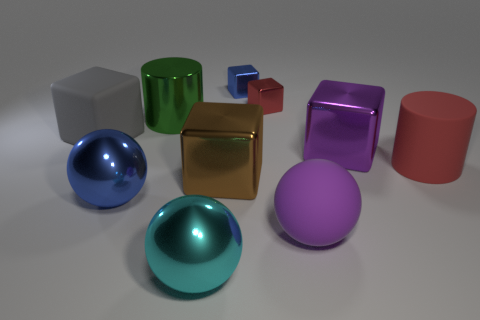Subtract all big shiny balls. How many balls are left? 1 Subtract all blue cubes. How many cubes are left? 4 Subtract all spheres. How many objects are left? 7 Add 3 metal objects. How many metal objects exist? 10 Subtract 1 red blocks. How many objects are left? 9 Subtract all green blocks. Subtract all blue spheres. How many blocks are left? 5 Subtract all green cylinders. Subtract all spheres. How many objects are left? 6 Add 2 cyan shiny spheres. How many cyan shiny spheres are left? 3 